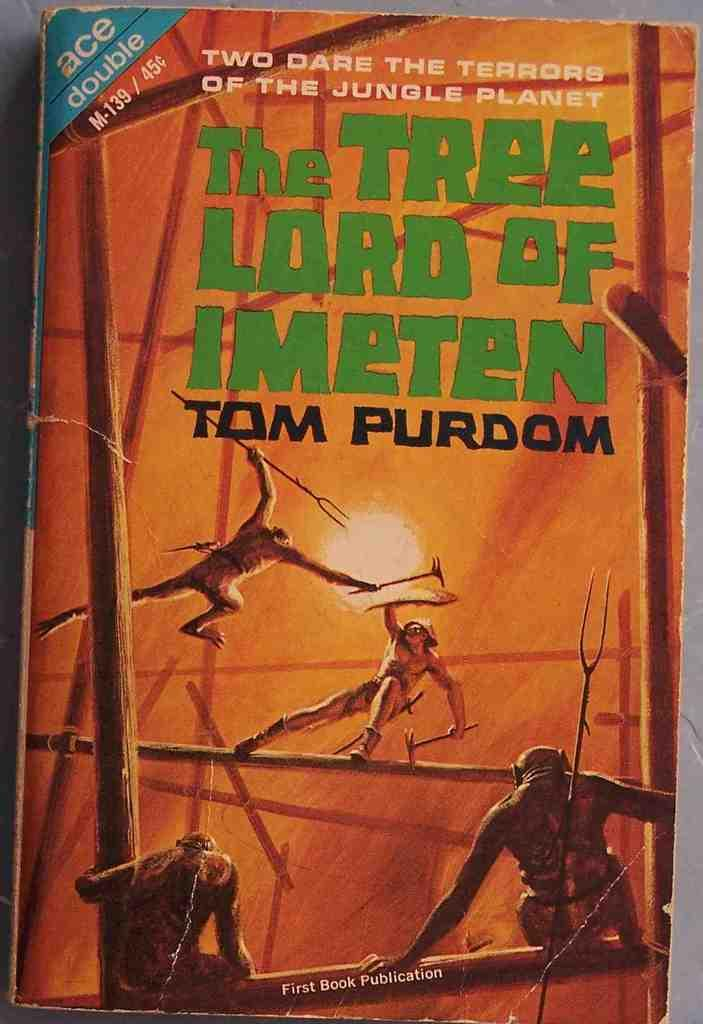<image>
Render a clear and concise summary of the photo. Tom Purdom wrote a book called The Tree Lord of Imeten 